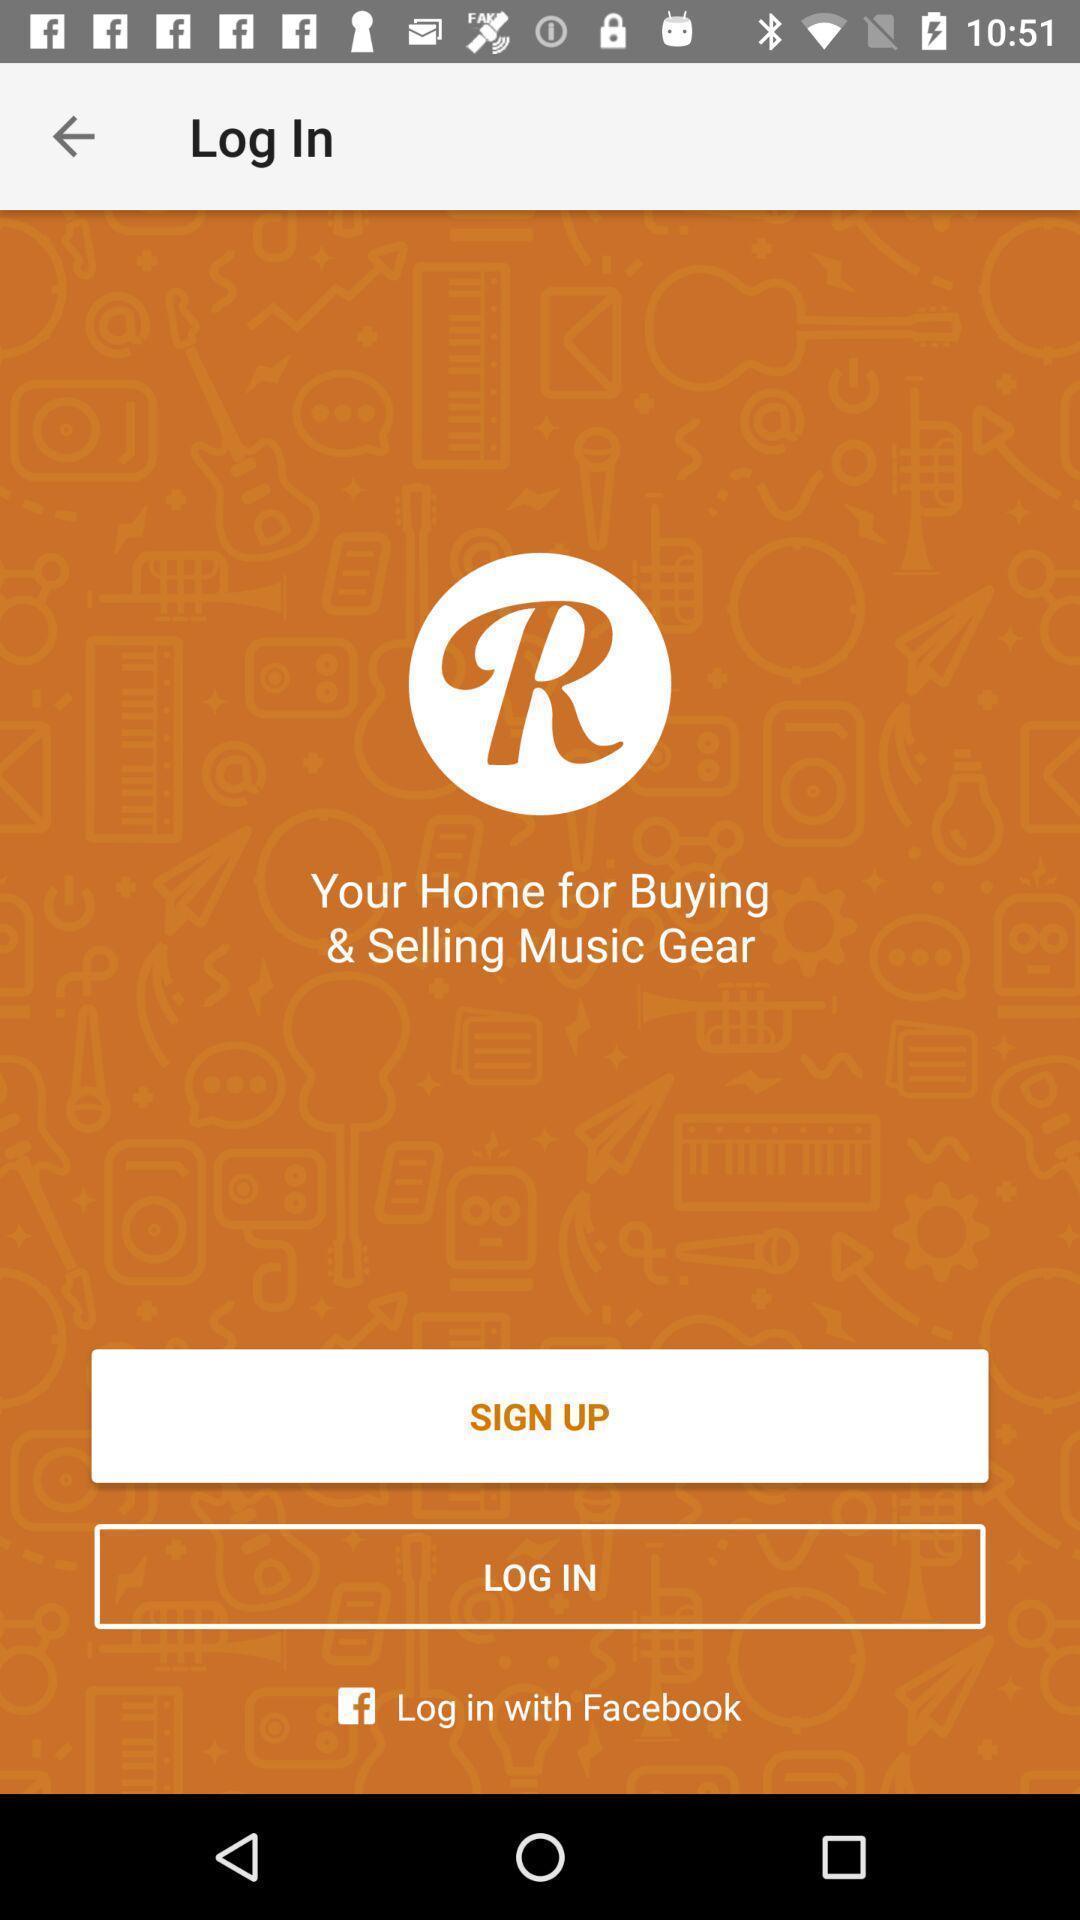Provide a detailed account of this screenshot. Welcome page for an app. 